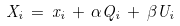<formula> <loc_0><loc_0><loc_500><loc_500>X _ { i } \, = \, x _ { i } \, + \, \alpha Q _ { i } \, + \, \beta U _ { i }</formula> 